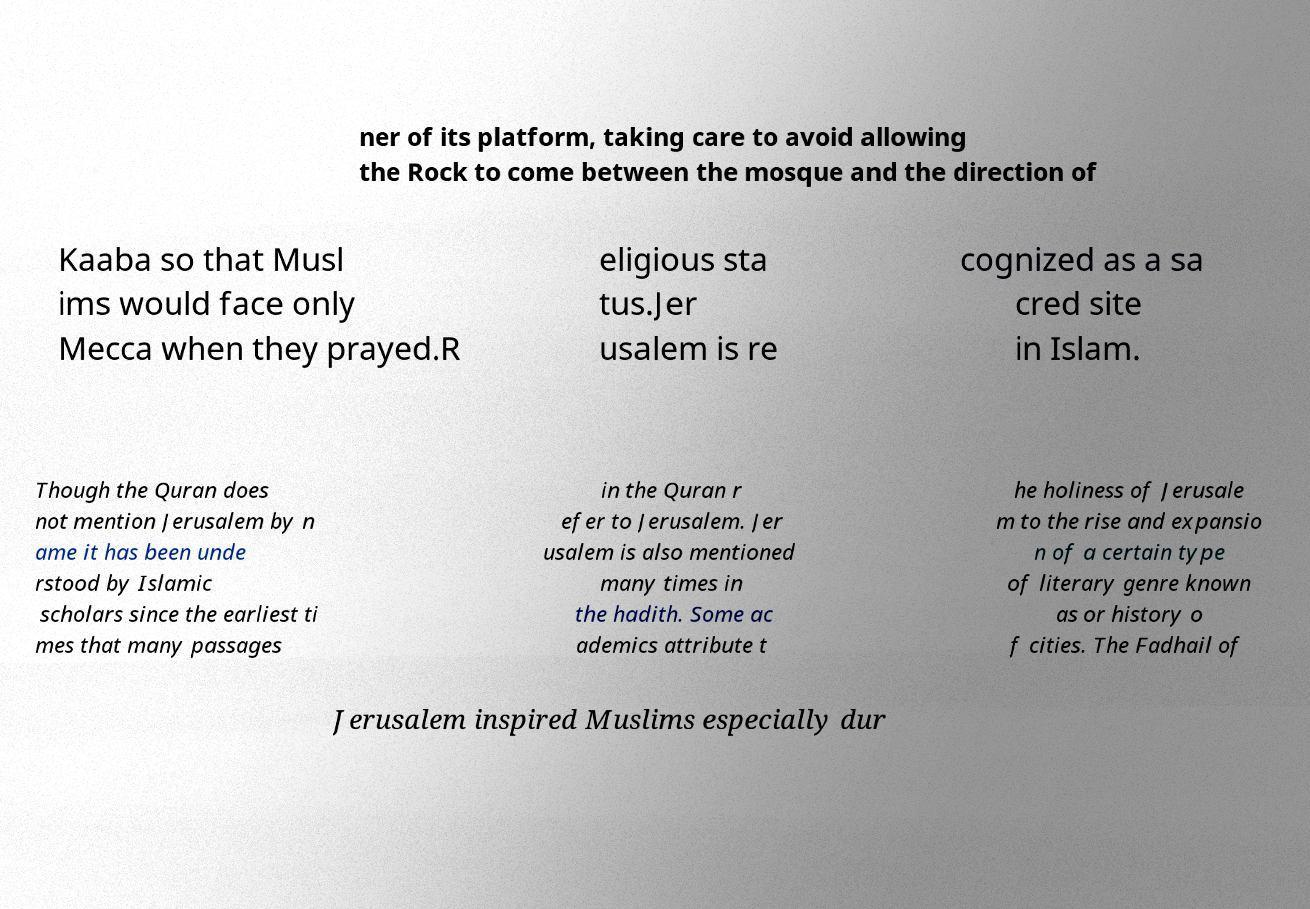Can you accurately transcribe the text from the provided image for me? ner of its platform, taking care to avoid allowing the Rock to come between the mosque and the direction of Kaaba so that Musl ims would face only Mecca when they prayed.R eligious sta tus.Jer usalem is re cognized as a sa cred site in Islam. Though the Quran does not mention Jerusalem by n ame it has been unde rstood by Islamic scholars since the earliest ti mes that many passages in the Quran r efer to Jerusalem. Jer usalem is also mentioned many times in the hadith. Some ac ademics attribute t he holiness of Jerusale m to the rise and expansio n of a certain type of literary genre known as or history o f cities. The Fadhail of Jerusalem inspired Muslims especially dur 